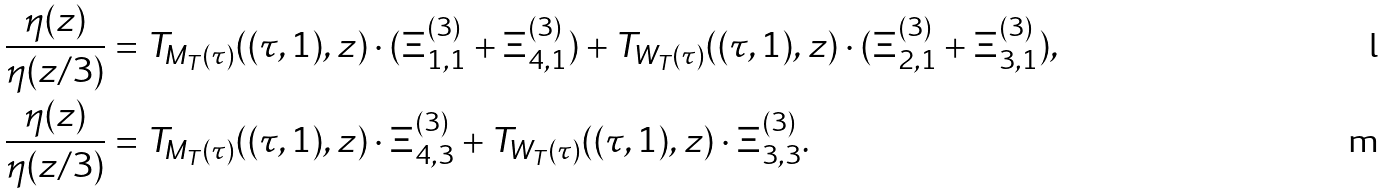<formula> <loc_0><loc_0><loc_500><loc_500>\frac { \eta ( z ) } { \eta ( z / 3 ) } & = T _ { M _ { T } ( \tau ) } ( ( \tau , 1 ) , z ) \cdot ( \Xi ^ { ( 3 ) } _ { 1 , 1 } + \Xi ^ { ( 3 ) } _ { 4 , 1 } ) + T _ { W _ { T } ( \tau ) } ( ( \tau , 1 ) , z ) \cdot ( \Xi ^ { ( 3 ) } _ { 2 , 1 } + \Xi ^ { ( 3 ) } _ { 3 , 1 } ) , \\ \frac { \eta ( z ) } { \eta ( z / 3 ) } & = T _ { M _ { T } ( \tau ) } ( ( \tau , 1 ) , z ) \cdot \Xi ^ { ( 3 ) } _ { 4 , 3 } + T _ { W _ { T } ( \tau ) } ( ( \tau , 1 ) , z ) \cdot \Xi ^ { ( 3 ) } _ { 3 , 3 } .</formula> 